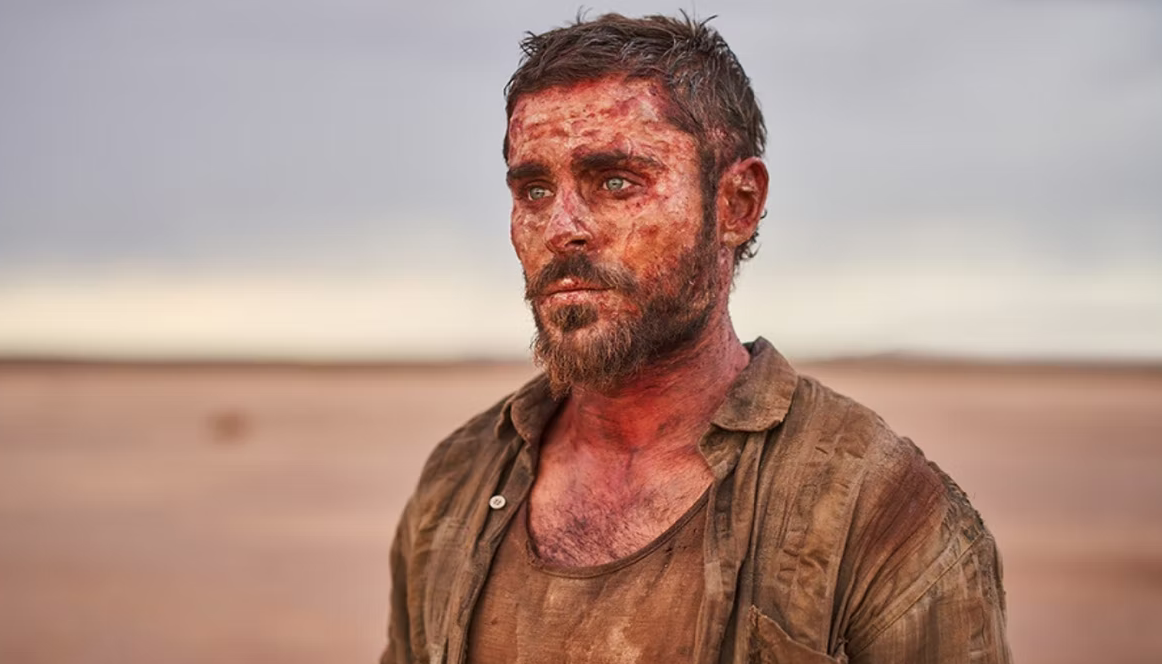Imagine if this character is part of a mythical world. What would his story be? In a mythical world, this character could be a fabled warrior who has been cursed to wander the barren wastelands. His mission might be to find a legendary artifact rumored to restore balance to the land, challenged by fantastical creatures and ancient spirits along the way. The dirt and blood on his body might not just be from physical battles but also from mystical trials set by ethereal beings testing his worthiness. The desert, with its enchanting pink hues, might be the gateway between realms, and his search could be the desperate attempt to save his homeland from a dark and enveloping doom. What if he encounters a mirage that turns out to be something unexpected? As he stares at the horizon, a shimmering oasis appears, drawing him closer with the promise of water and shelter. However, as he reaches out to touch the seemingly clear water, the mirage dissipates, revealing an ancient guardian. This spectral figure, cloaked in the sands, speaks of a hidden kingdom beneath the desert, accessible only to those who prove their valor. Our character, though exhausted, pledges to uncover this hidden world, thus beginning a new and exhilarating chapter in his legend. 